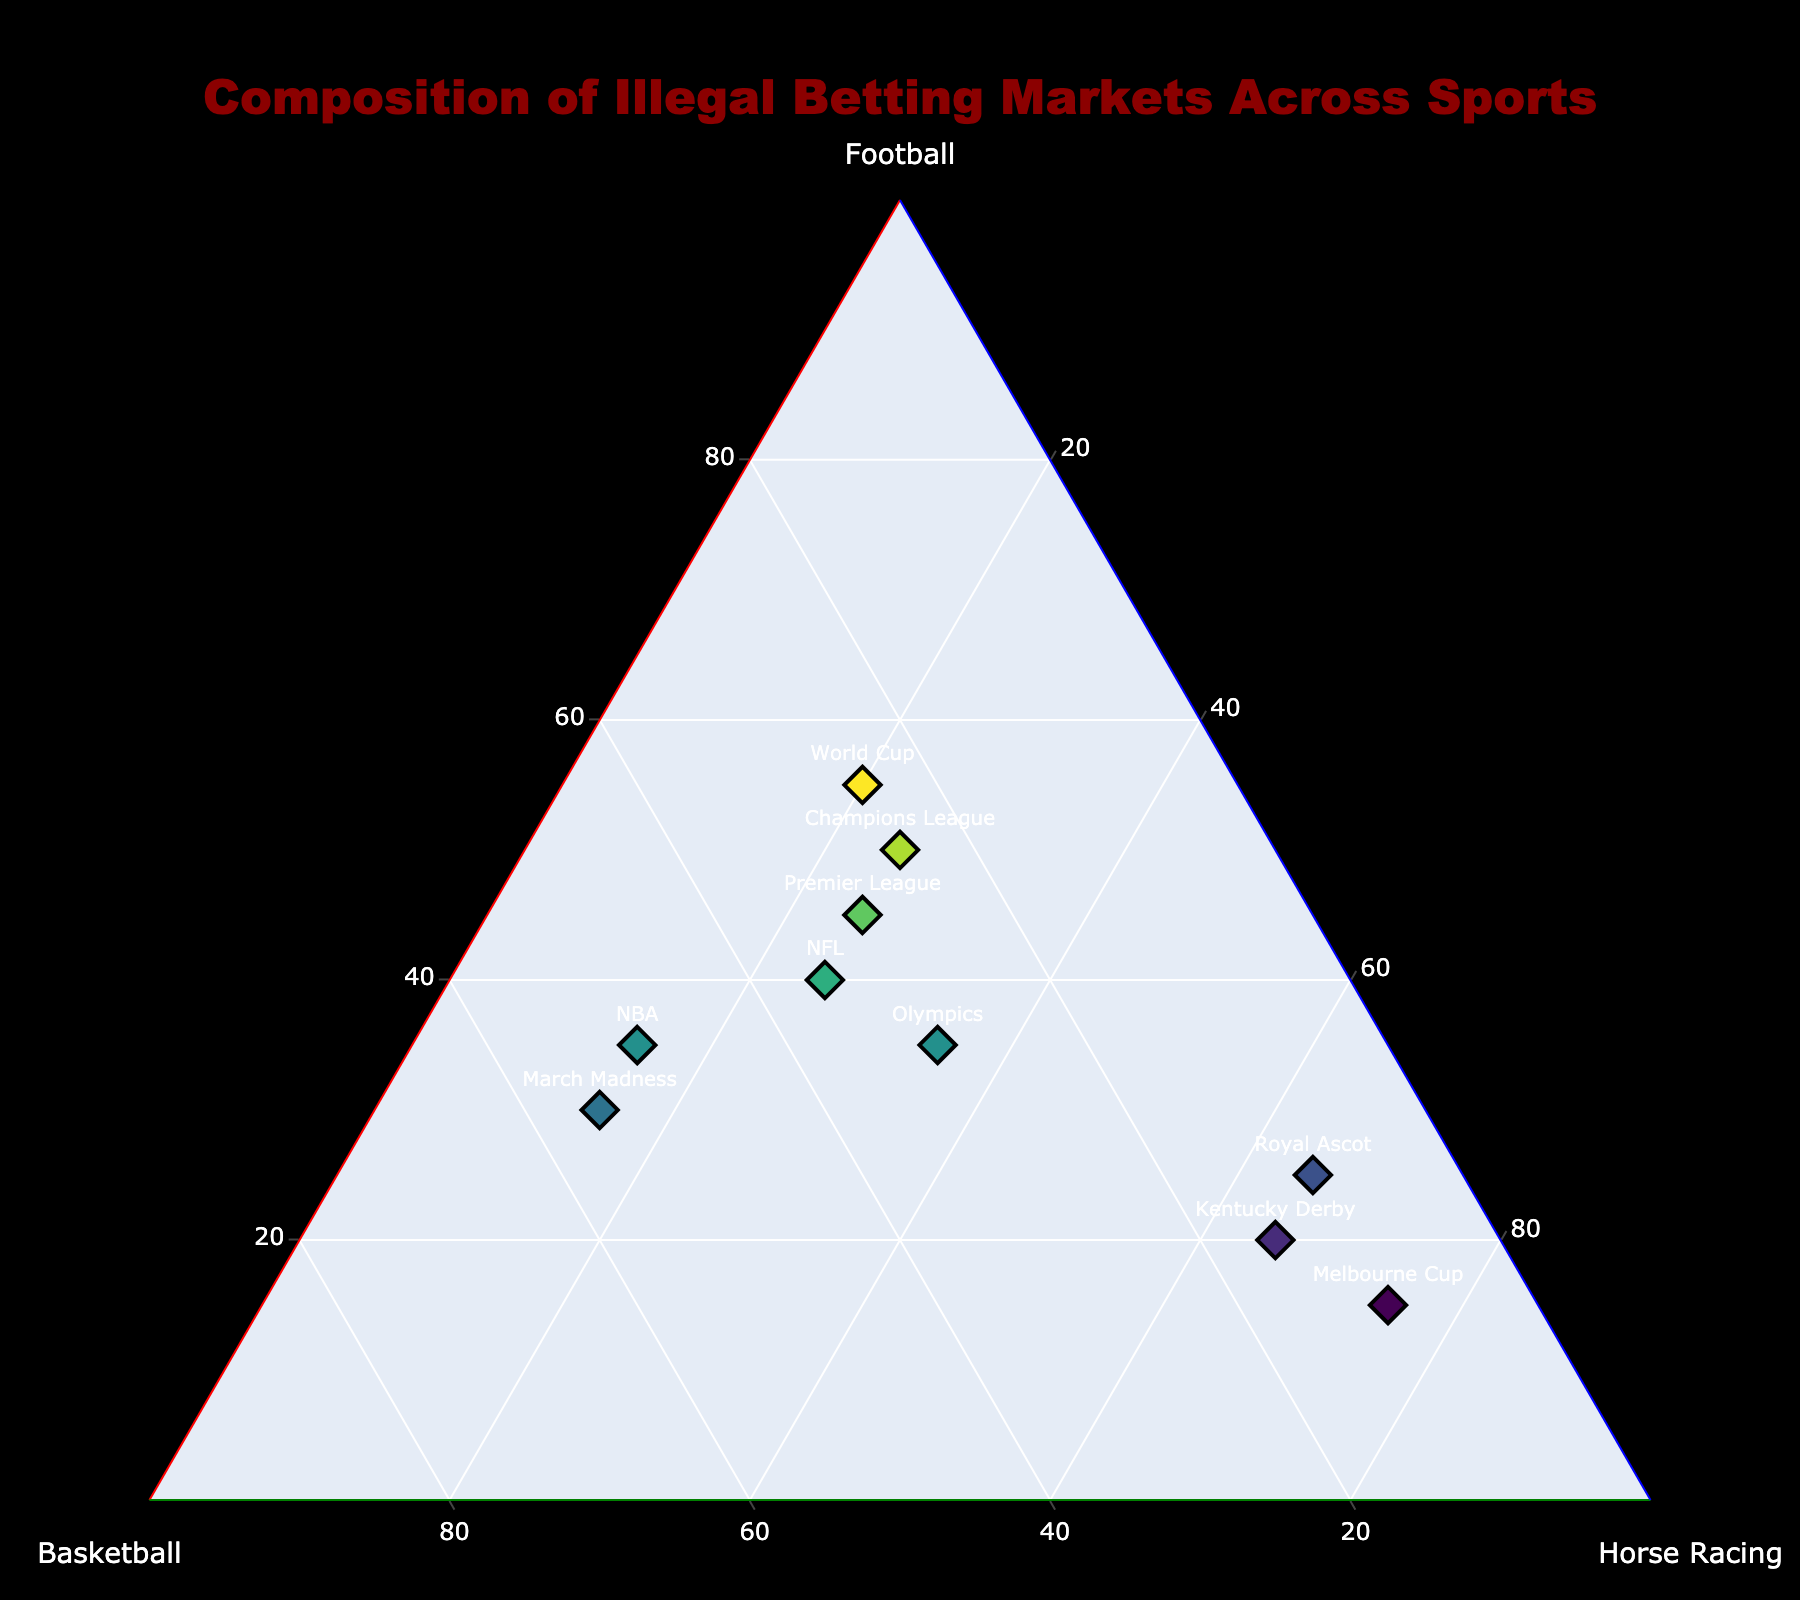What's the title of the figure? The title is usually placed at the top of the figure and is designed to provide a brief summary of what the figure represents. In this case, the title is: "Composition of Illegal Betting Markets Across Sports".
Answer: Composition of Illegal Betting Markets Across Sports How many data points are shown in the plot? By observing the number of labeled markers on the plot, each representing a different sport, we can count the total number of data points. The figure includes: Premier League, NBA, Kentucky Derby, Champions League, March Madness, Melbourne Cup, NFL, Olympics, Royal Ascot, and World Cup.
Answer: 10 Which sport has the highest proportion of illegal betting in football? To determine this, we need to look for the data point positioned closest to the 'Football' corner of the ternary plot. The 'Football' axis ranges from minimum at the central line to maximum at the corner. The World Cup, with 55% for football, is closest to this edge.
Answer: World Cup What is the combined percentage of basketball in Premier League and NBA? Add up the percentage values from the 'Basketball' axis for Premier League (30%) and NBA (50%). 30 + 50 = 80
Answer: 80 Which sport has the lowest combined percentage for football and horse racing? We need to identify the sport where the sum of 'Football' and 'Horse Racing' values is the smallest. For each sport: Premier League (45+25=70), NBA (35+15=50), Kentucky Derby (20+65=85), Champions League (50+25=75), March Madness (30+15=45), Melbourne Cup (15+75=90), NFL (40+25=65), Olympics (35+35=70), Royal Ascot (25+65=90), World Cup (55+20=75). March Madness has the lowest total (45).
Answer: March Madness Which sport is closest to having an equal distribution of illegal betting among football, basketball, and horse racing? Find the data points that appear near the center of the ternary plot, which indicates a more balanced distribution. Olympics, with 35% football, 30% basketball, and 35% horse racing, fits this description.
Answer: Olympics Compare the illegal betting between Premier League and Champions League. Which has a higher proportion in horse racing? To answer this, we look at the 'Horse Racing' values for both sports. Premier League has 25%, and Champions League also has 25% in horse racing. Therefore, both have equal proportions.
Answer: Both are equal What's the average football percentage across all sports? Calculate the average of the football percentages by summing up all football values and dividing by the number of sports. Sum: 45+35+20+50+30+15+40+35+25+55 = 350. There are 10 sports, so average is 350/10 = 35.
Answer: 35 Which sport has the second highest basketball betting percentage? First, identify the sport with the highest basketball betting percentage: March Madness with 55%. Next, determine the sport with the second highest: NBA with 50%.
Answer: NBA 